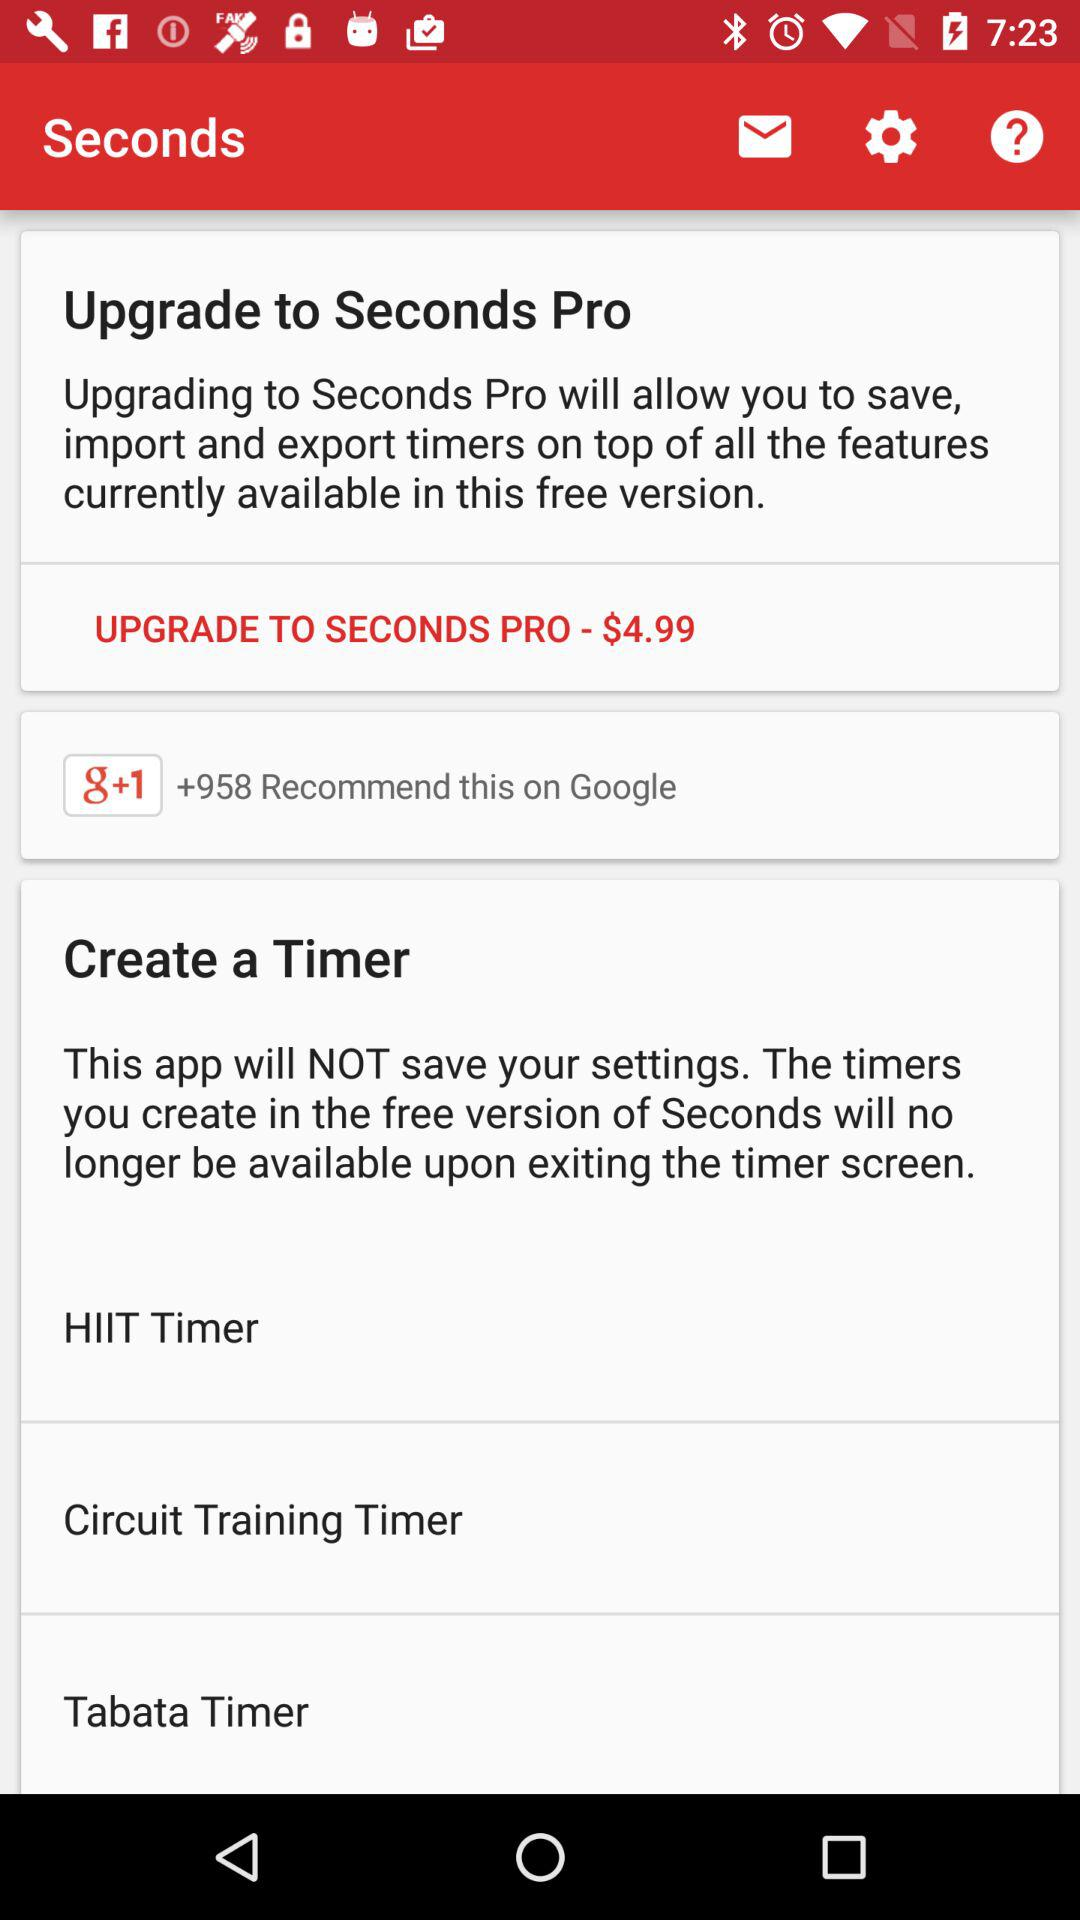How many timers are available in the free version of Seconds?
Answer the question using a single word or phrase. 3 